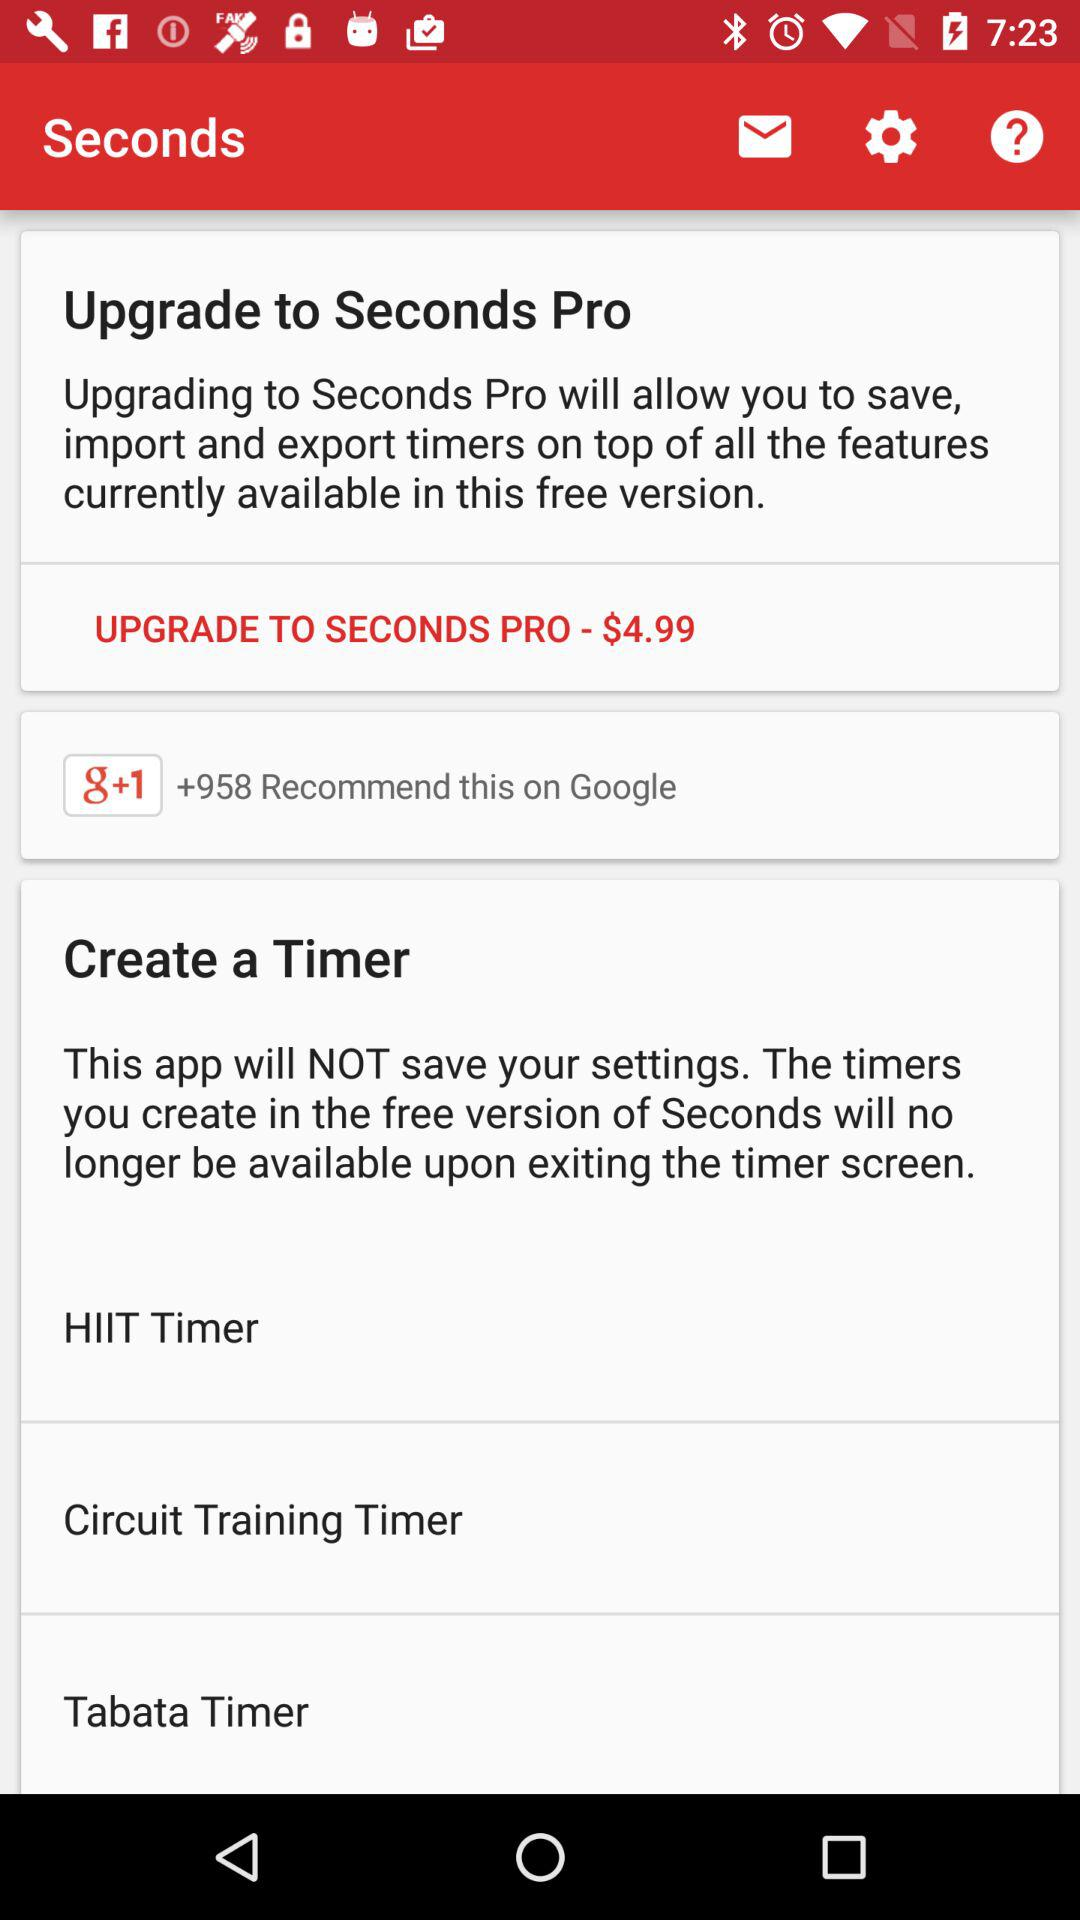How many timers are available in the free version of Seconds?
Answer the question using a single word or phrase. 3 